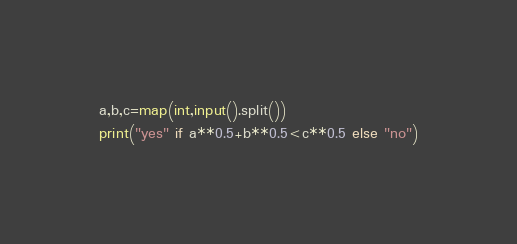Convert code to text. <code><loc_0><loc_0><loc_500><loc_500><_Python_>a,b,c=map(int,input().split())
print("yes" if a**0.5+b**0.5<c**0.5 else "no")</code> 